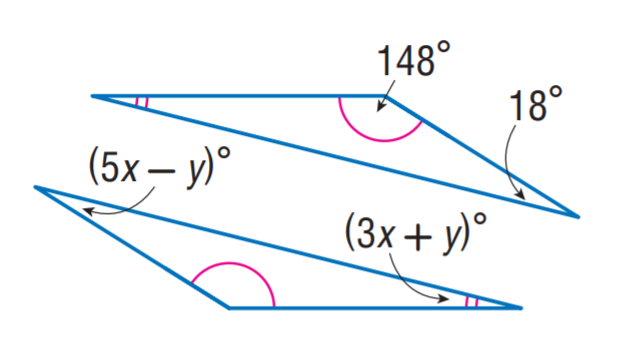Question: Find x.
Choices:
A. 2
B. 3
C. 4
D. 5
Answer with the letter. Answer: C Question: Find y.
Choices:
A. 2
B. 3
C. 4
D. 5
Answer with the letter. Answer: A 